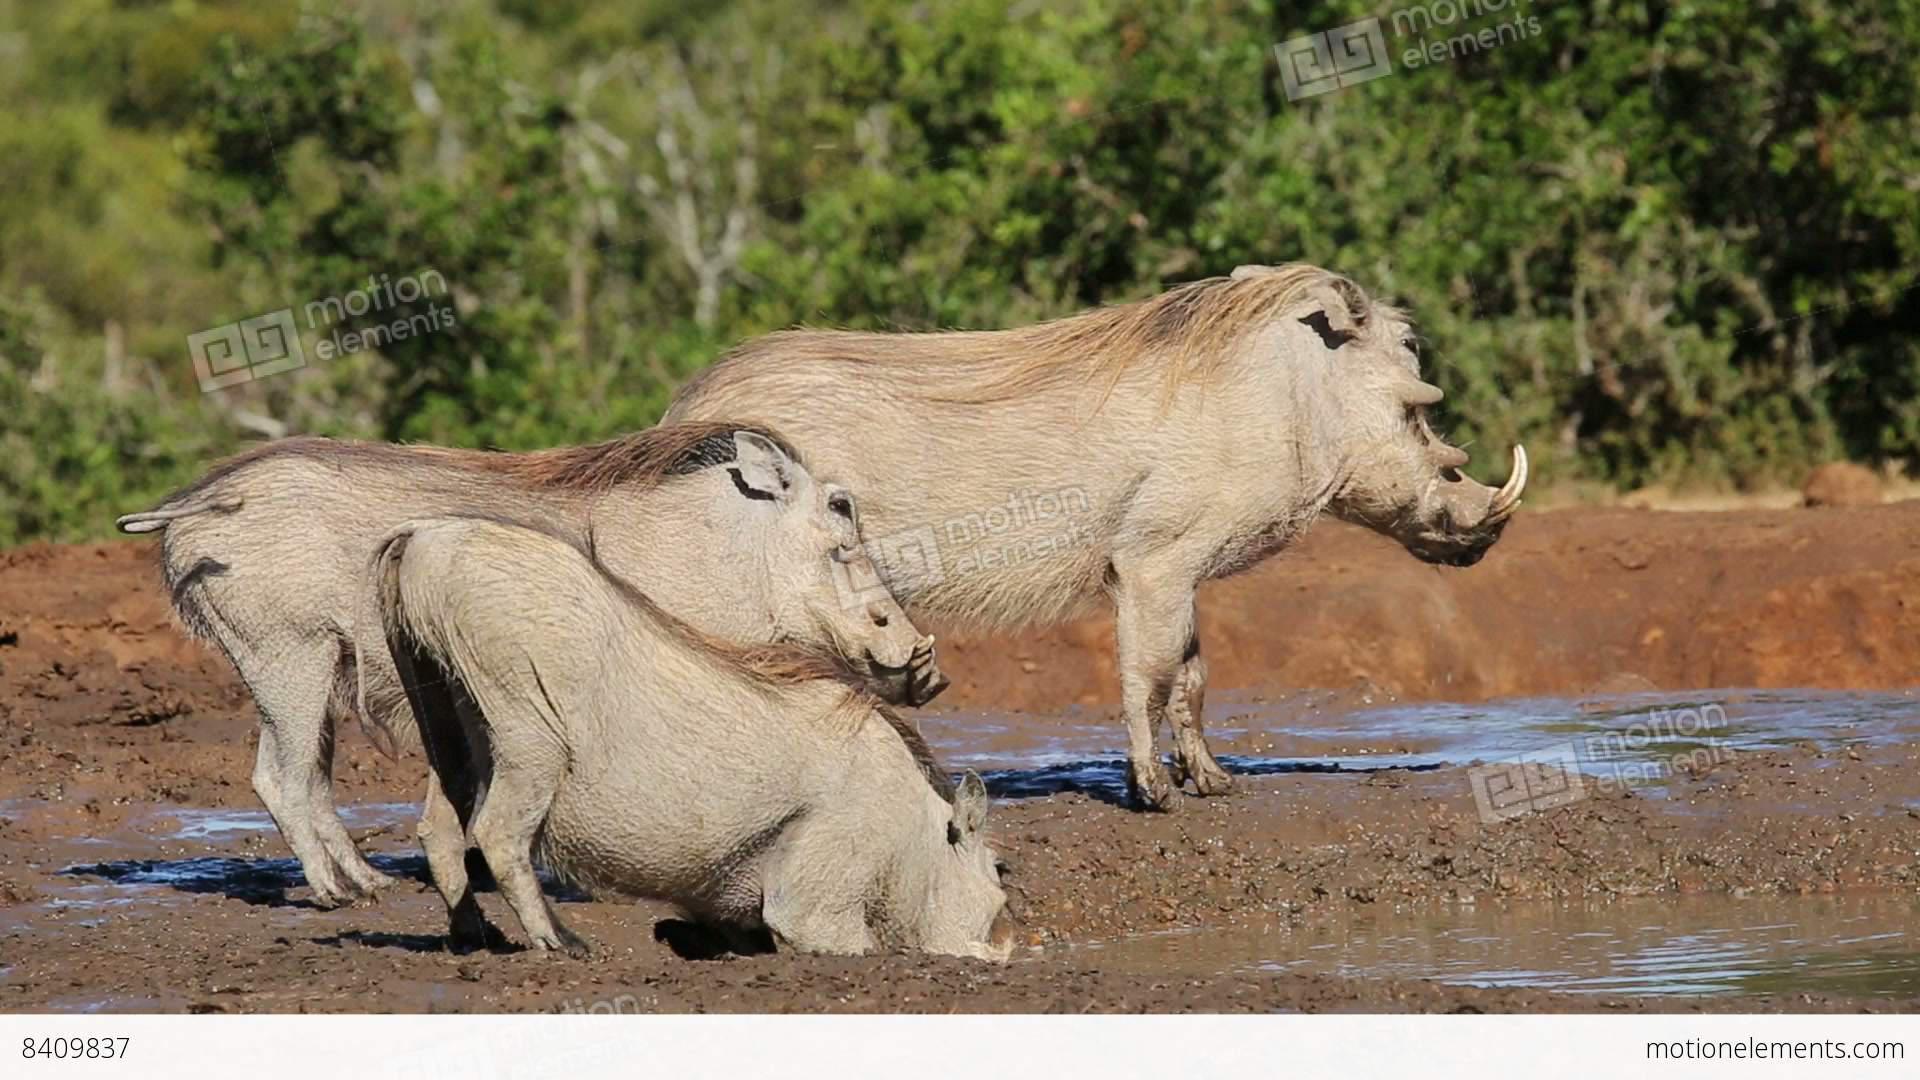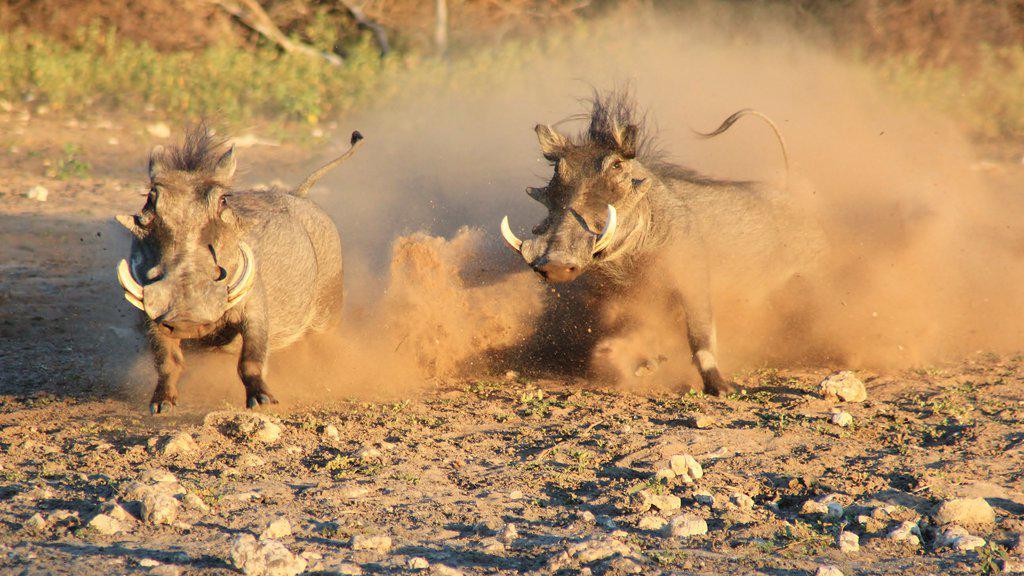The first image is the image on the left, the second image is the image on the right. Examine the images to the left and right. Is the description "Multiple warthogs stand at the edge of a muddy hole." accurate? Answer yes or no. Yes. The first image is the image on the left, the second image is the image on the right. Assess this claim about the two images: "There is no more than one warthog in the left image.". Correct or not? Answer yes or no. No. 